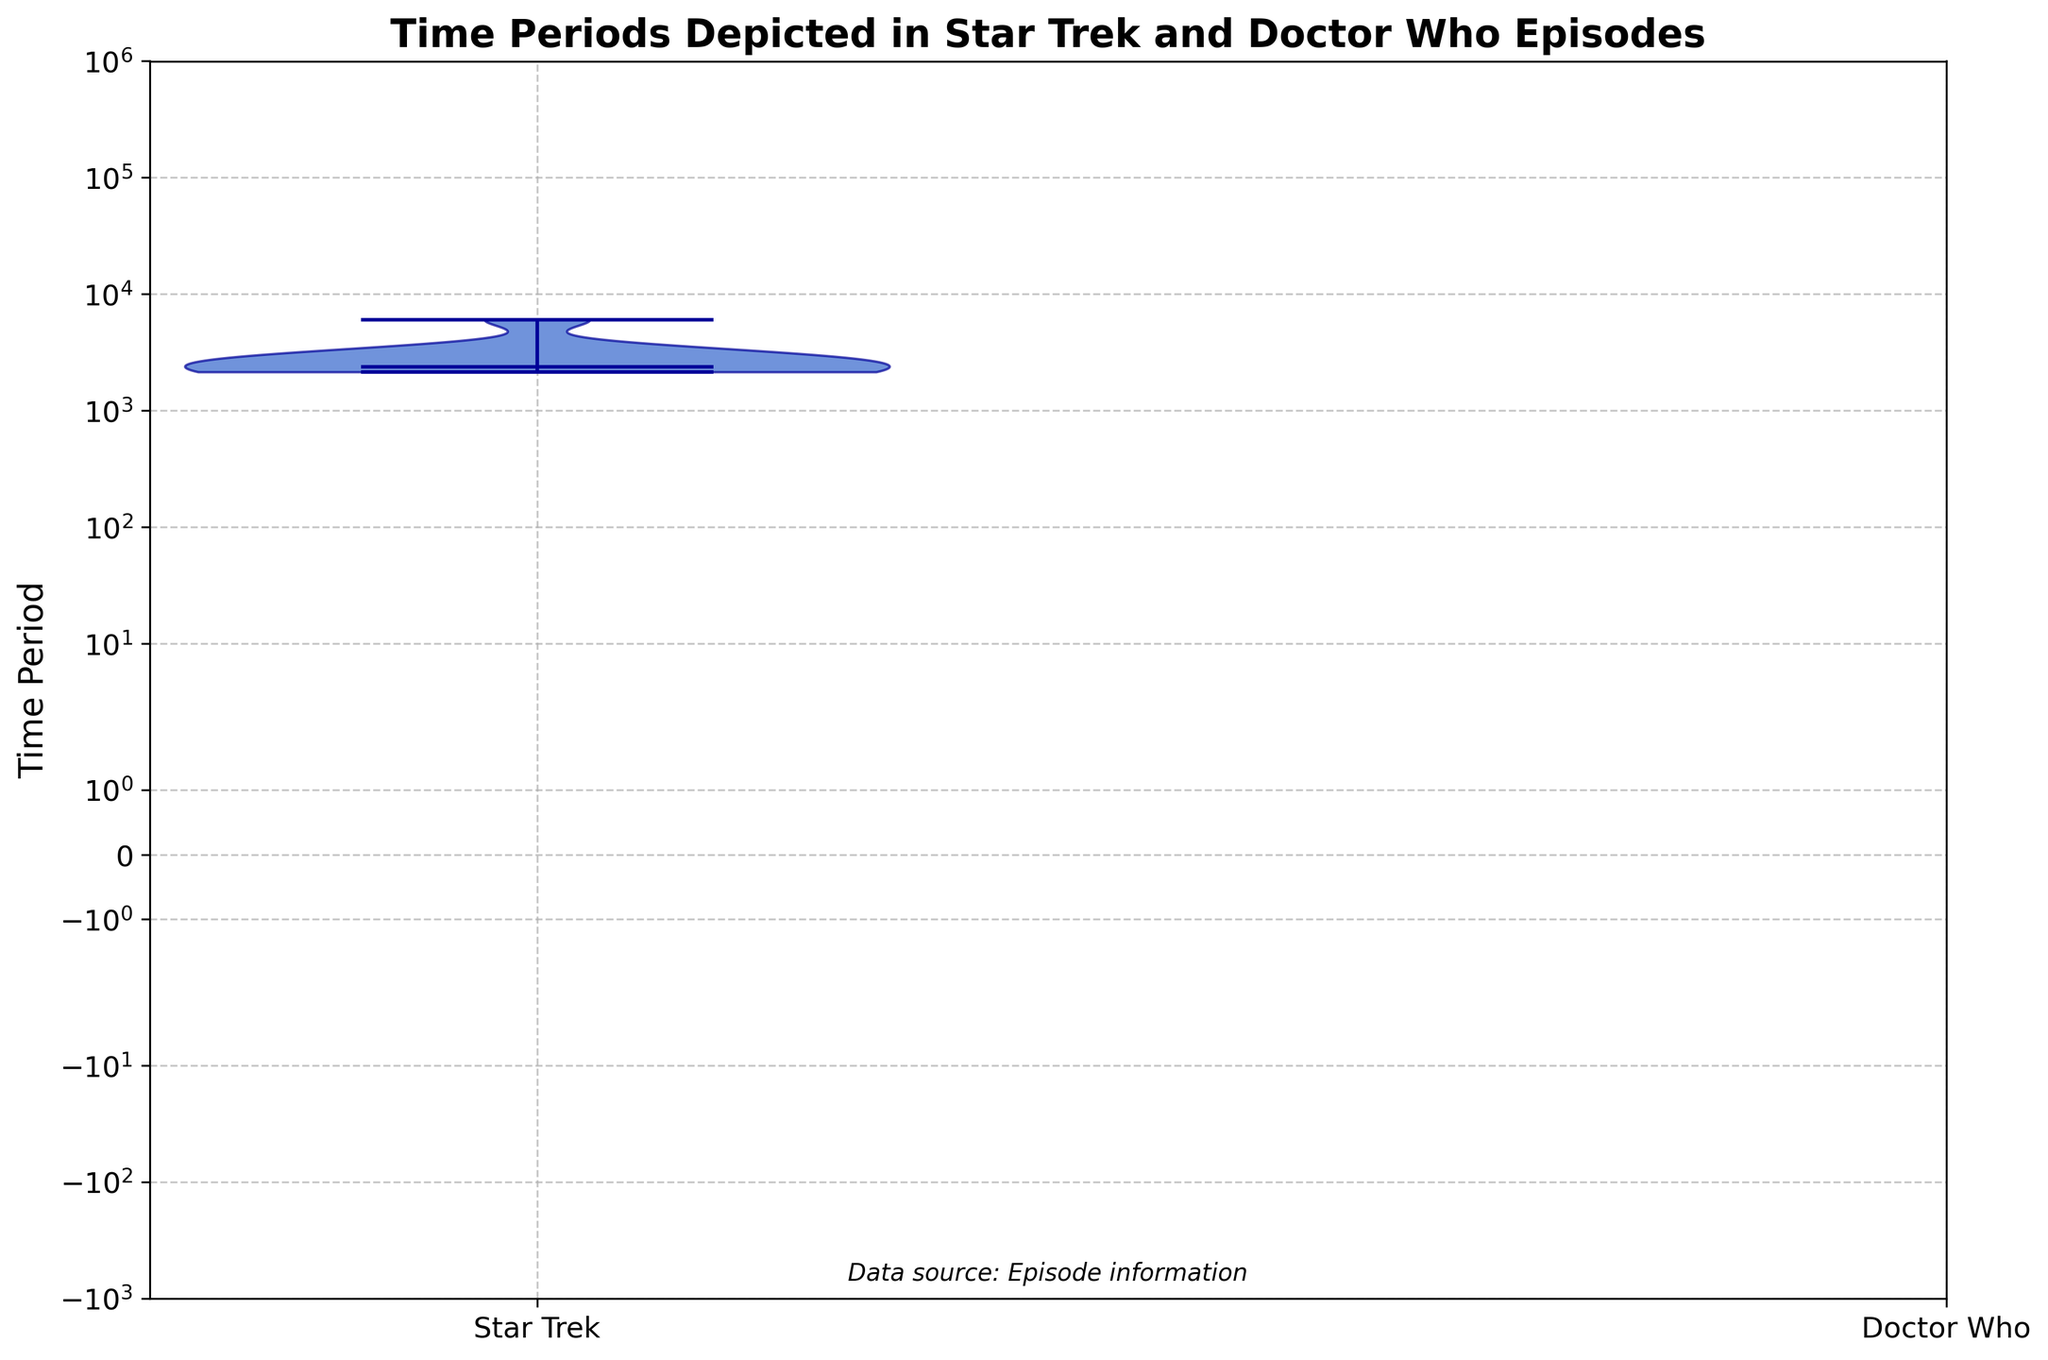What's the title of the figure? The title is written at the top of the figure. It shows what the chart is representing.
Answer: Time Periods Depicted in Star Trek and Doctor Who Episodes What are the series represented in the figure? The series are indicated by the x-axis labels. There are two labels, one for each series.
Answer: Star Trek and Doctor Who What type of scale is used for the y-axis? By examining the y-axis closely, you can see that the intervals between values increase exponentially, indicating a logarithmic scale.
Answer: Logarithmic Which series has episodes depicting time periods that range over a longer span on the y-axis? The span can be observed by noting the lowest and highest points of each series on the y-axis.
Answer: Doctor Who What is the median time period for Star Trek episodes? The median is represented by the horizontal line inside each violin plot. For Star Trek, it is around 2364.
Answer: 2364 Which series shows depictions of earlier historical periods? By looking at the smaller time period values on the y-axis for each series, Doctor Who represents earlier historical periods.
Answer: Doctor Who What is the lowest time period represented in Doctor Who episodes? The lowest value in the violin plot for Doctor Who touches around 100000 BC.
Answer: 100000 BC Which series has a wider distribution of time periods depicted in its episodes? A wider distribution is shown by a more expanded and spread out violin plot.
Answer: Doctor Who How does the time period distribution of Doctor Who compare to that of Star Trek in terms of skewness? The shape of the violin plot helps us determine skewness. Doctor Who's plot is more stretched at the lower end indicating a skew towards earlier periods.
Answer: Doctor Who's time periods are more positively skewed 